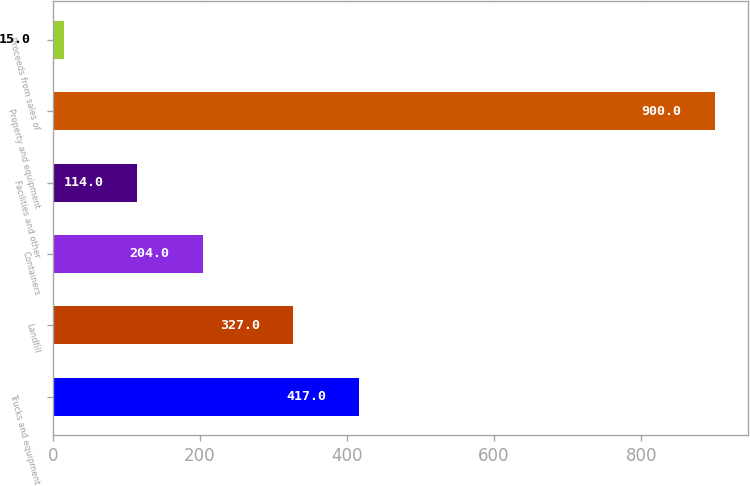Convert chart. <chart><loc_0><loc_0><loc_500><loc_500><bar_chart><fcel>Trucks and equipment<fcel>Landfill<fcel>Containers<fcel>Facilities and other<fcel>Property and equipment<fcel>Proceeds from sales of<nl><fcel>417<fcel>327<fcel>204<fcel>114<fcel>900<fcel>15<nl></chart> 